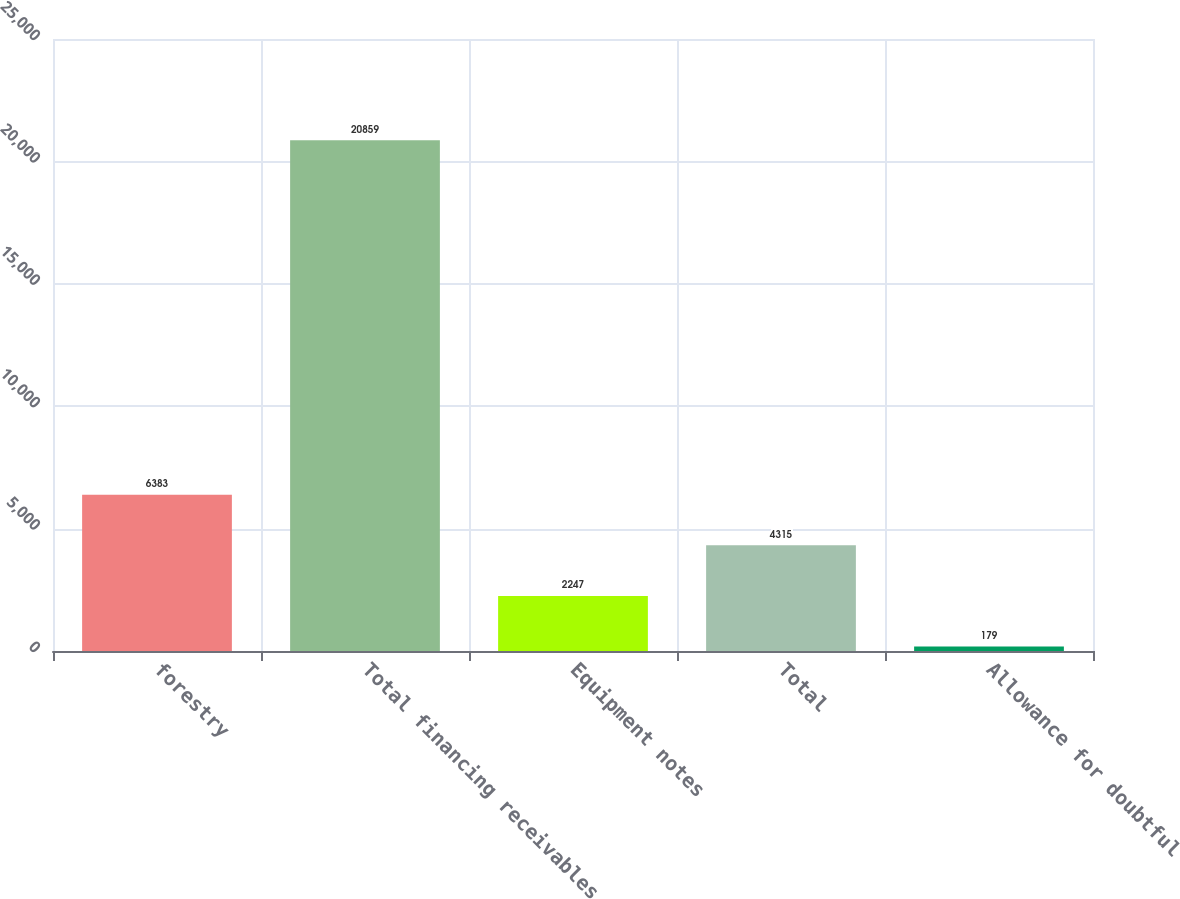Convert chart. <chart><loc_0><loc_0><loc_500><loc_500><bar_chart><fcel>forestry<fcel>Total financing receivables<fcel>Equipment notes<fcel>Total<fcel>Allowance for doubtful<nl><fcel>6383<fcel>20859<fcel>2247<fcel>4315<fcel>179<nl></chart> 